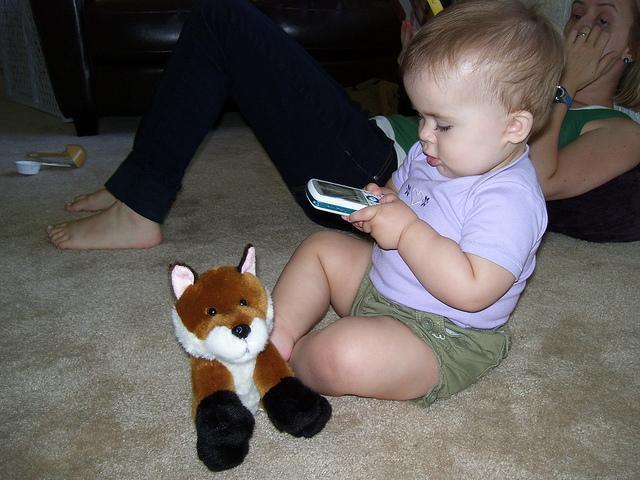How many people are in the photo?
Give a very brief answer. 2. 